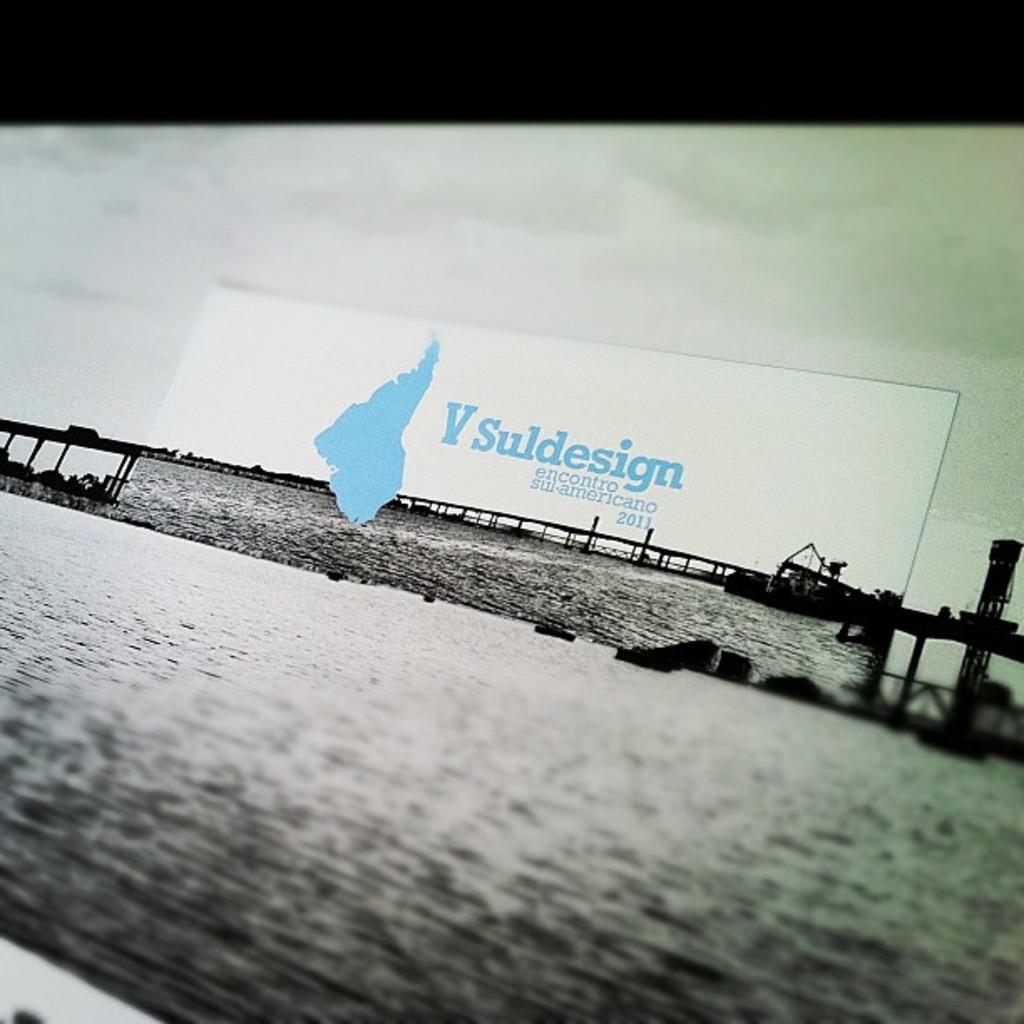Provide a one-sentence caption for the provided image. A billboard sign with the name V Suldesign near the bridge over the water. 